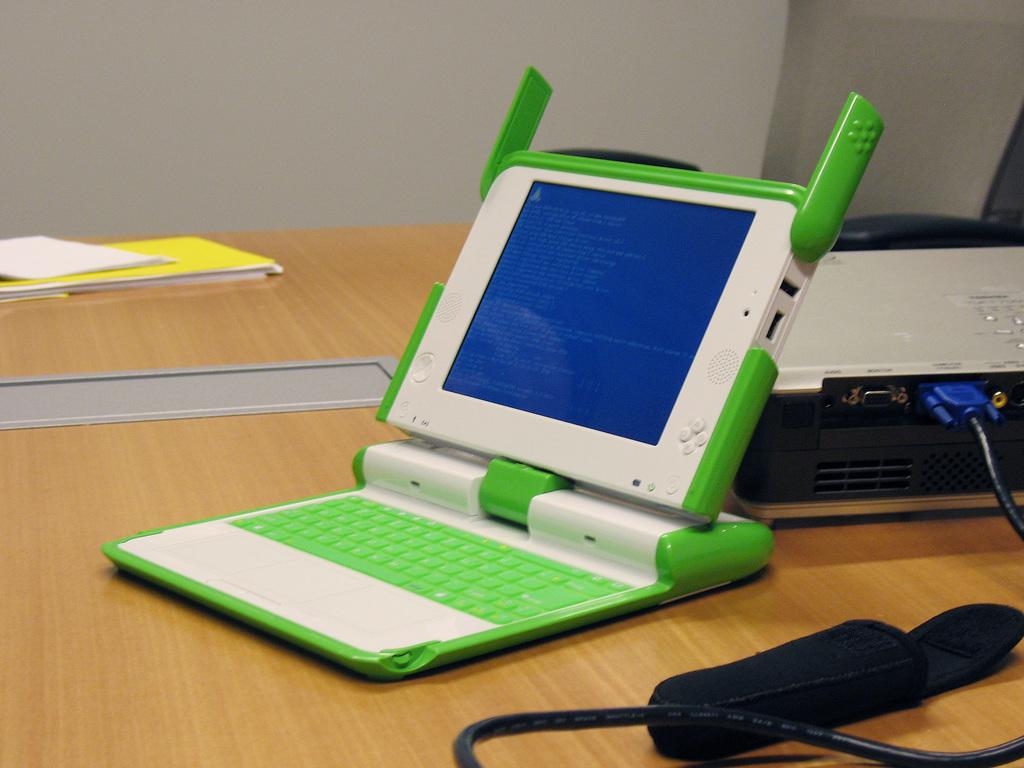What piece of furniture is present in the image? There is a table in the image. What electronic device is on the table? There is a laptop on the table. What type of reading material is on the table? There is a book on the table. What other device is on the table? There is a projector on the table. What type of chance game is being played on the table in the image? There is no chance game present in the image; it features a table with a laptop, book, and projector. What type of pump is visible on the table in the image? There is no pump present in the image; it features a table with a laptop, book, and projector. 